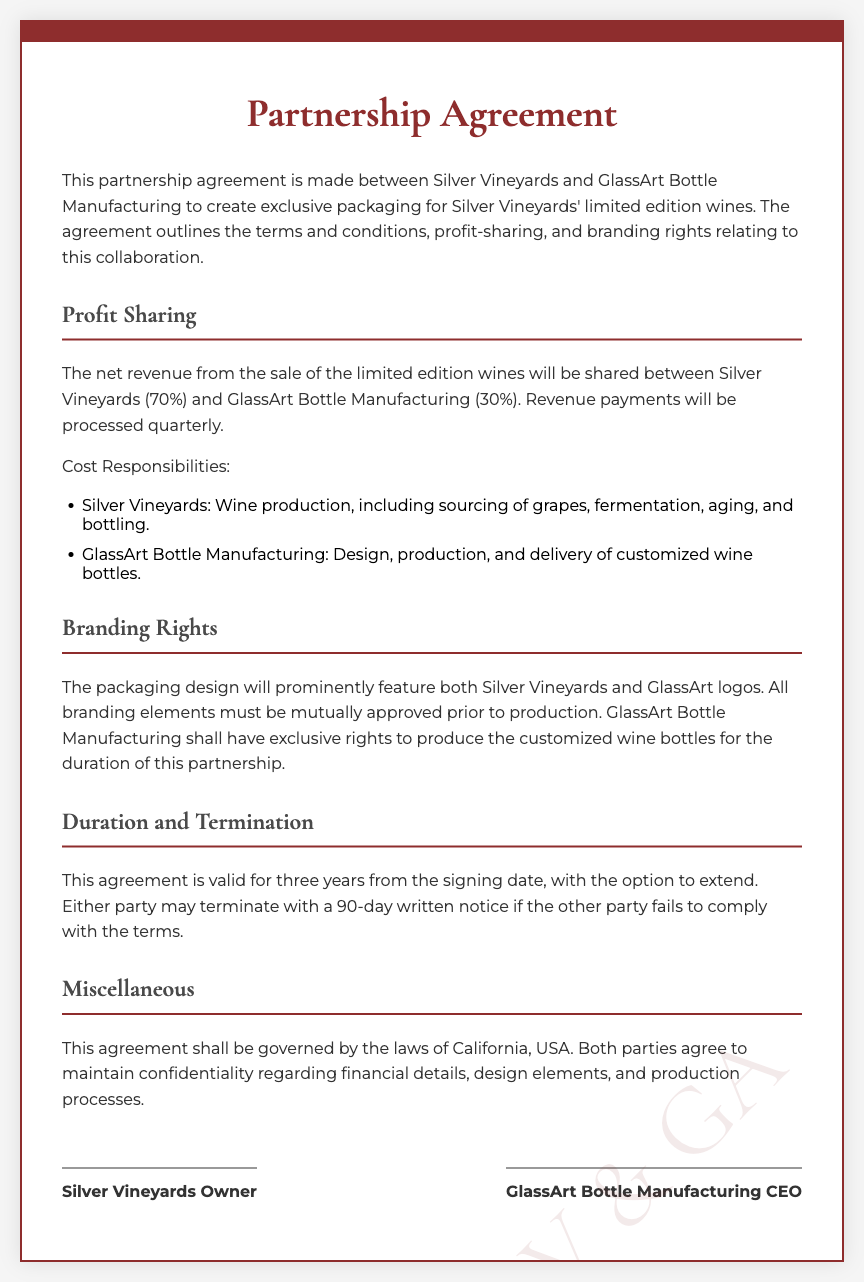What is the profit share for Silver Vineyards? The document states that the profit share for Silver Vineyards is 70%.
Answer: 70% What is the profit share for GlassArt Bottle Manufacturing? The document states that the profit share for GlassArt Bottle Manufacturing is 30%.
Answer: 30% How long is the agreement valid? The document indicates that the agreement is valid for three years.
Answer: three years What is required for branding approval? The document specifies that all branding elements must be mutually approved prior to production.
Answer: mutually approved What notice period is needed for termination? The document mentions a 90-day written notice is required for termination.
Answer: 90-day Who assumes the cost of wine production? The document states that Silver Vineyards is responsible for wine production costs.
Answer: Silver Vineyards What company manufactures the customized wine bottles? The document states that GlassArt Bottle Manufacturing is responsible for manufacturing the customized wine bottles.
Answer: GlassArt Bottle Manufacturing Under which jurisdiction is the agreement governed? The document specifies that the agreement shall be governed by the laws of California, USA.
Answer: California, USA What happens if a party fails to comply with the terms? The document indicates that the other party may terminate with a 90-day written notice if compliance fails.
Answer: terminate with a 90-day notice Who signs the agreement on behalf of Silver Vineyards? The document mentions "Silver Vineyards Owner" as the signatory.
Answer: Silver Vineyards Owner 